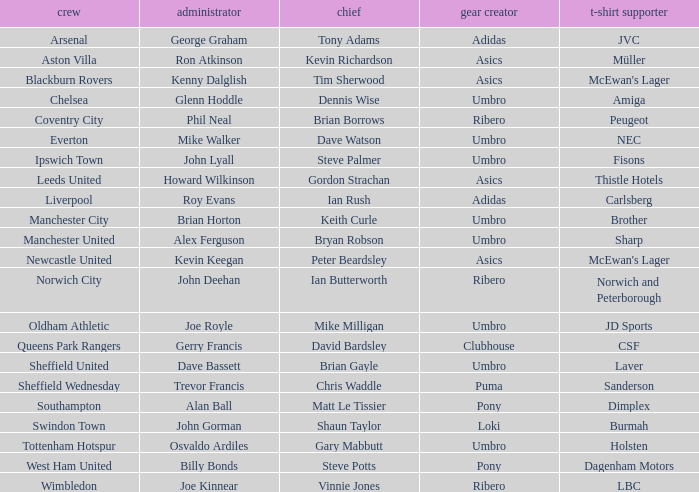Which manager has Manchester City as the team? Brian Horton. 